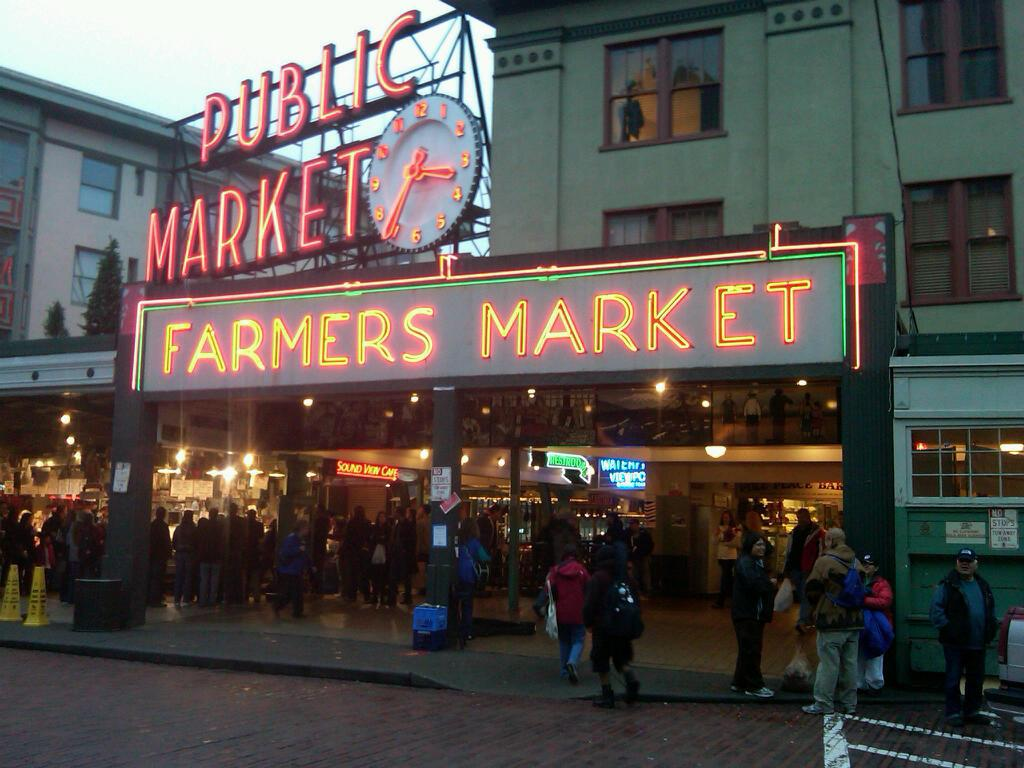Who or what can be seen in the image? People are present in the image. What type of structures are visible in the image? There are buildings in the image. What electronic signage is present in the image? There is an LED board on the top of the image and an LED hoarding in the image. What time-telling device is beside the LED hoarding? There is a clock beside the LED hoarding. What type of vegetation is at the left back of the image? There are trees at the left back of the image. What part of the natural environment is visible in the image? The sky is visible at the top of the image. What type of riddle is being solved by the people in the image? There is no riddle being solved by the people in the image; they are simply present. What authority figure is depicted in the image? There is no authority figure depicted in the image. What type of poison is being used by the people in the image? There is no poison present or being used in the image. 